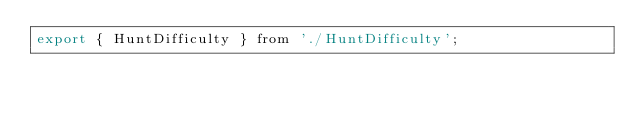<code> <loc_0><loc_0><loc_500><loc_500><_JavaScript_>export { HuntDifficulty } from './HuntDifficulty';
</code> 